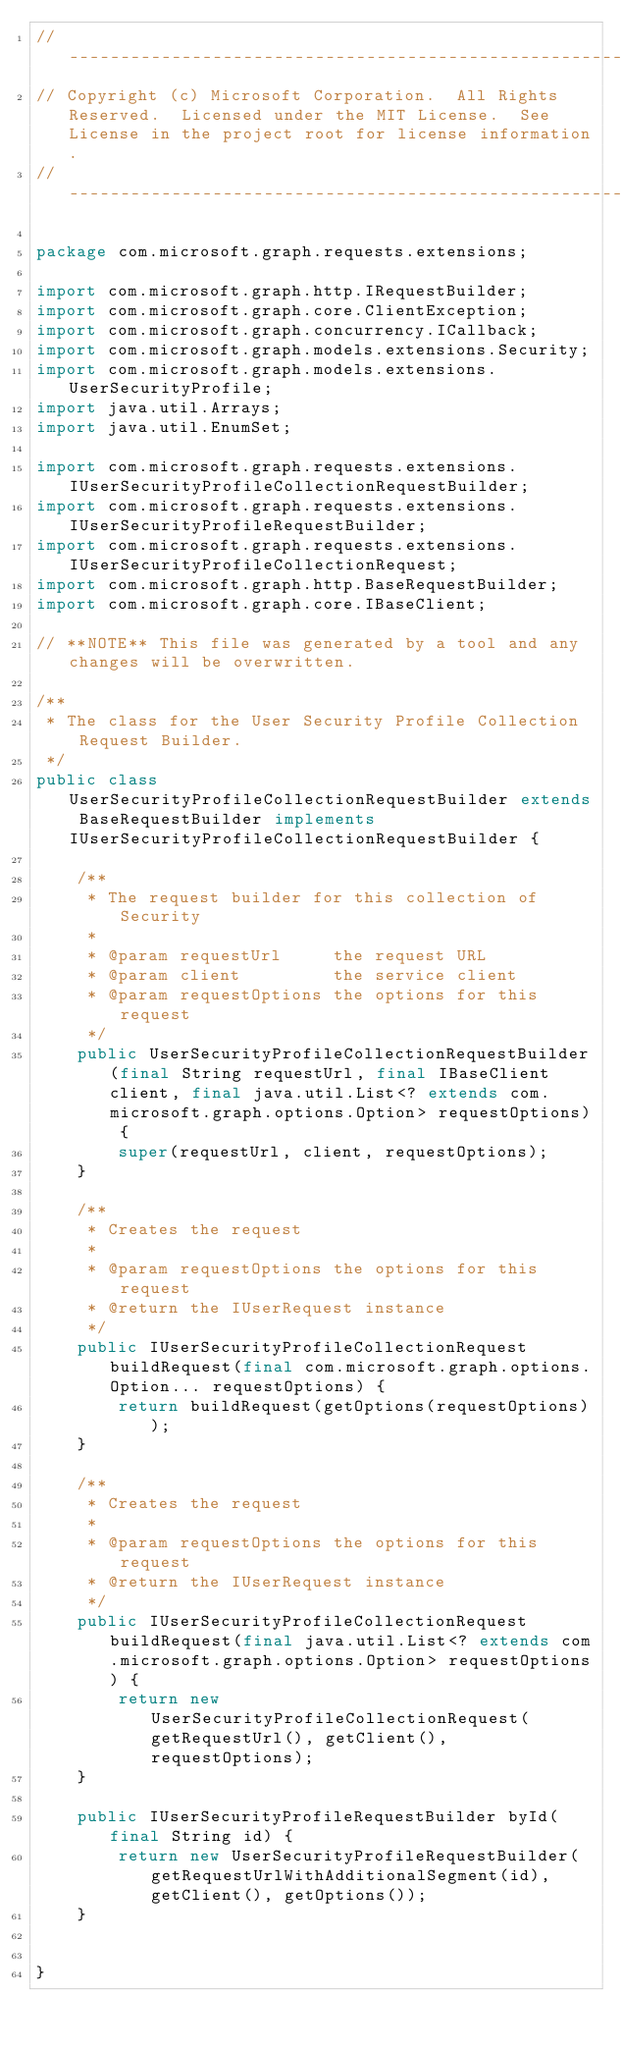Convert code to text. <code><loc_0><loc_0><loc_500><loc_500><_Java_>// ------------------------------------------------------------------------------
// Copyright (c) Microsoft Corporation.  All Rights Reserved.  Licensed under the MIT License.  See License in the project root for license information.
// ------------------------------------------------------------------------------

package com.microsoft.graph.requests.extensions;

import com.microsoft.graph.http.IRequestBuilder;
import com.microsoft.graph.core.ClientException;
import com.microsoft.graph.concurrency.ICallback;
import com.microsoft.graph.models.extensions.Security;
import com.microsoft.graph.models.extensions.UserSecurityProfile;
import java.util.Arrays;
import java.util.EnumSet;

import com.microsoft.graph.requests.extensions.IUserSecurityProfileCollectionRequestBuilder;
import com.microsoft.graph.requests.extensions.IUserSecurityProfileRequestBuilder;
import com.microsoft.graph.requests.extensions.IUserSecurityProfileCollectionRequest;
import com.microsoft.graph.http.BaseRequestBuilder;
import com.microsoft.graph.core.IBaseClient;

// **NOTE** This file was generated by a tool and any changes will be overwritten.

/**
 * The class for the User Security Profile Collection Request Builder.
 */
public class UserSecurityProfileCollectionRequestBuilder extends BaseRequestBuilder implements IUserSecurityProfileCollectionRequestBuilder {

    /**
     * The request builder for this collection of Security
     *
     * @param requestUrl     the request URL
     * @param client         the service client
     * @param requestOptions the options for this request
     */
    public UserSecurityProfileCollectionRequestBuilder(final String requestUrl, final IBaseClient client, final java.util.List<? extends com.microsoft.graph.options.Option> requestOptions) {
        super(requestUrl, client, requestOptions);
    }

    /**
     * Creates the request
     *
     * @param requestOptions the options for this request
     * @return the IUserRequest instance
     */
    public IUserSecurityProfileCollectionRequest buildRequest(final com.microsoft.graph.options.Option... requestOptions) {
        return buildRequest(getOptions(requestOptions));
    }

    /**
     * Creates the request
     *
     * @param requestOptions the options for this request
     * @return the IUserRequest instance
     */
    public IUserSecurityProfileCollectionRequest buildRequest(final java.util.List<? extends com.microsoft.graph.options.Option> requestOptions) {
        return new UserSecurityProfileCollectionRequest(getRequestUrl(), getClient(), requestOptions);
    }

    public IUserSecurityProfileRequestBuilder byId(final String id) {
        return new UserSecurityProfileRequestBuilder(getRequestUrlWithAdditionalSegment(id), getClient(), getOptions());
    }


}
</code> 